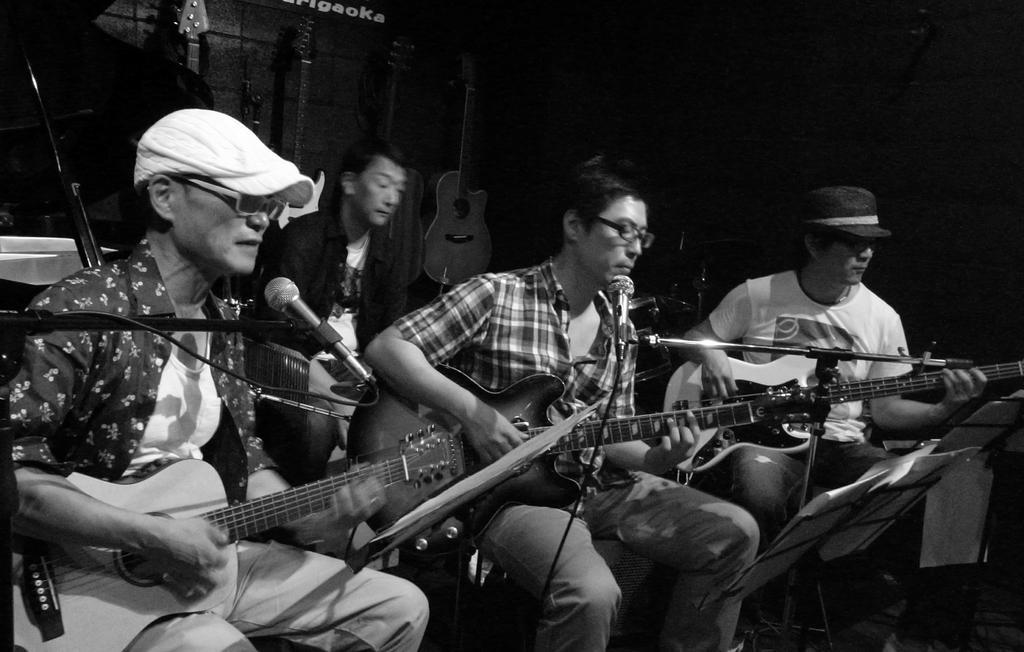Could you give a brief overview of what you see in this image? In this Image I see 4 men who are sitting and these 3 are holding the guitars and there are mics in front of them. In the background I see few guitars on the wall. 